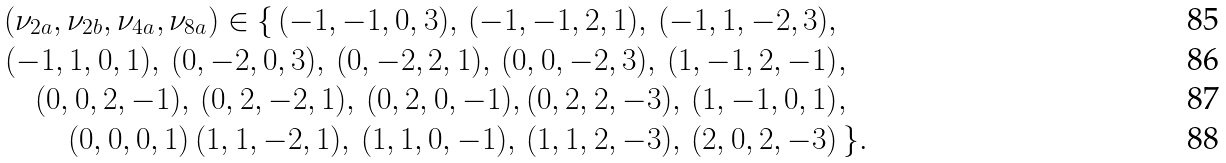<formula> <loc_0><loc_0><loc_500><loc_500>( \nu _ { 2 a } , \nu _ { 2 b } , \nu _ { 4 a } , \nu _ { 8 a } ) \in \{ \, ( - 1 , - 1 , 0 , 3 ) , \, ( - 1 , - 1 , 2 , 1 ) , \, ( - 1 , 1 , - 2 , 3 ) , & \\ ( - 1 , 1 , 0 , 1 ) , \, ( 0 , - 2 , 0 , 3 ) , \, ( 0 , - 2 , 2 , 1 ) , \, ( 0 , 0 , - 2 , 3 ) , \, ( 1 , - 1 , 2 , - 1 ) & , \\ ( 0 , 0 , 2 , - 1 ) , \, ( 0 , 2 , - 2 , 1 ) , \, ( 0 , 2 , 0 , - 1 ) , ( 0 , 2 , 2 , - 3 ) , \, ( 1 , - 1 , 0 , 1 ) & , \\ ( 0 , 0 , 0 , 1 ) \, ( 1 , 1 , - 2 , 1 ) , \, ( 1 , 1 , 0 , - 1 ) , \, ( 1 , 1 , 2 , - 3 ) , \, ( 2 , 0 , 2 , - 3 ) & \, \} .</formula> 